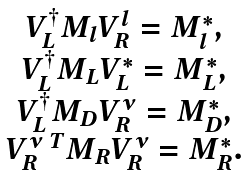Convert formula to latex. <formula><loc_0><loc_0><loc_500><loc_500>\begin{array} { c } { V ^ { \dagger } _ { L } } M _ { l } { V ^ { l } _ { R } } = { M ^ { * } _ { l } } , \\ { V ^ { \dagger } _ { L } } M _ { L } { V ^ { * } _ { L } } = { M ^ { * } _ { L } } , \\ { V ^ { \dagger } _ { L } } M _ { D } { V ^ { \nu } _ { R } } = { M ^ { * } _ { D } } , \\ { V ^ { \nu \ T } _ { R } } M _ { R } V ^ { \nu } _ { R } = { M ^ { * } _ { R } } . \end{array}</formula> 